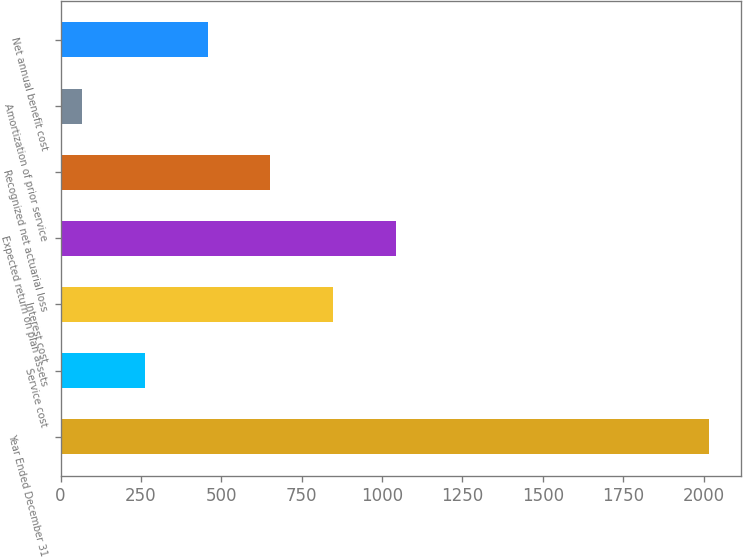<chart> <loc_0><loc_0><loc_500><loc_500><bar_chart><fcel>Year Ended December 31<fcel>Service cost<fcel>Interest cost<fcel>Expected return on plan assets<fcel>Recognized net actuarial loss<fcel>Amortization of prior service<fcel>Net annual benefit cost<nl><fcel>2016<fcel>262.8<fcel>847.2<fcel>1042<fcel>652.4<fcel>68<fcel>457.6<nl></chart> 